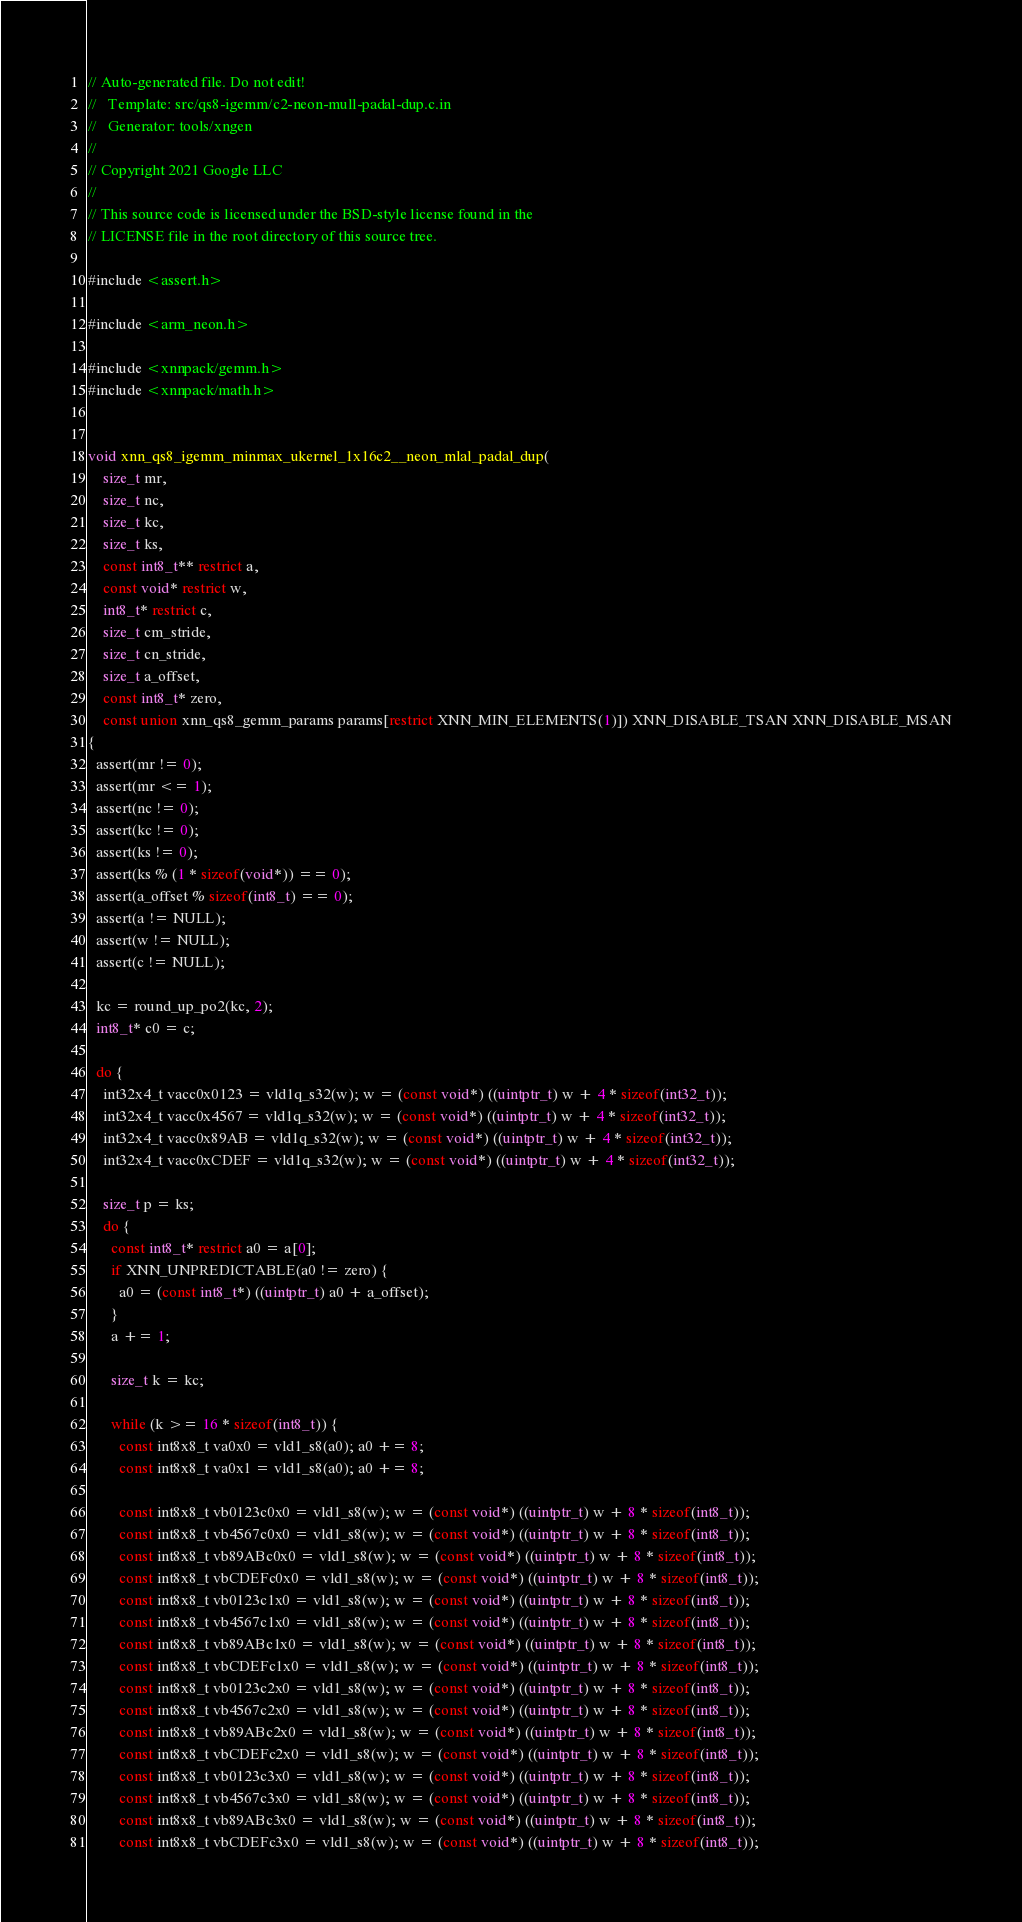Convert code to text. <code><loc_0><loc_0><loc_500><loc_500><_C_>// Auto-generated file. Do not edit!
//   Template: src/qs8-igemm/c2-neon-mull-padal-dup.c.in
//   Generator: tools/xngen
//
// Copyright 2021 Google LLC
//
// This source code is licensed under the BSD-style license found in the
// LICENSE file in the root directory of this source tree.

#include <assert.h>

#include <arm_neon.h>

#include <xnnpack/gemm.h>
#include <xnnpack/math.h>


void xnn_qs8_igemm_minmax_ukernel_1x16c2__neon_mlal_padal_dup(
    size_t mr,
    size_t nc,
    size_t kc,
    size_t ks,
    const int8_t** restrict a,
    const void* restrict w,
    int8_t* restrict c,
    size_t cm_stride,
    size_t cn_stride,
    size_t a_offset,
    const int8_t* zero,
    const union xnn_qs8_gemm_params params[restrict XNN_MIN_ELEMENTS(1)]) XNN_DISABLE_TSAN XNN_DISABLE_MSAN
{
  assert(mr != 0);
  assert(mr <= 1);
  assert(nc != 0);
  assert(kc != 0);
  assert(ks != 0);
  assert(ks % (1 * sizeof(void*)) == 0);
  assert(a_offset % sizeof(int8_t) == 0);
  assert(a != NULL);
  assert(w != NULL);
  assert(c != NULL);

  kc = round_up_po2(kc, 2);
  int8_t* c0 = c;

  do {
    int32x4_t vacc0x0123 = vld1q_s32(w); w = (const void*) ((uintptr_t) w + 4 * sizeof(int32_t));
    int32x4_t vacc0x4567 = vld1q_s32(w); w = (const void*) ((uintptr_t) w + 4 * sizeof(int32_t));
    int32x4_t vacc0x89AB = vld1q_s32(w); w = (const void*) ((uintptr_t) w + 4 * sizeof(int32_t));
    int32x4_t vacc0xCDEF = vld1q_s32(w); w = (const void*) ((uintptr_t) w + 4 * sizeof(int32_t));

    size_t p = ks;
    do {
      const int8_t* restrict a0 = a[0];
      if XNN_UNPREDICTABLE(a0 != zero) {
        a0 = (const int8_t*) ((uintptr_t) a0 + a_offset);
      }
      a += 1;

      size_t k = kc;

      while (k >= 16 * sizeof(int8_t)) {
        const int8x8_t va0x0 = vld1_s8(a0); a0 += 8;
        const int8x8_t va0x1 = vld1_s8(a0); a0 += 8;

        const int8x8_t vb0123c0x0 = vld1_s8(w); w = (const void*) ((uintptr_t) w + 8 * sizeof(int8_t));
        const int8x8_t vb4567c0x0 = vld1_s8(w); w = (const void*) ((uintptr_t) w + 8 * sizeof(int8_t));
        const int8x8_t vb89ABc0x0 = vld1_s8(w); w = (const void*) ((uintptr_t) w + 8 * sizeof(int8_t));
        const int8x8_t vbCDEFc0x0 = vld1_s8(w); w = (const void*) ((uintptr_t) w + 8 * sizeof(int8_t));
        const int8x8_t vb0123c1x0 = vld1_s8(w); w = (const void*) ((uintptr_t) w + 8 * sizeof(int8_t));
        const int8x8_t vb4567c1x0 = vld1_s8(w); w = (const void*) ((uintptr_t) w + 8 * sizeof(int8_t));
        const int8x8_t vb89ABc1x0 = vld1_s8(w); w = (const void*) ((uintptr_t) w + 8 * sizeof(int8_t));
        const int8x8_t vbCDEFc1x0 = vld1_s8(w); w = (const void*) ((uintptr_t) w + 8 * sizeof(int8_t));
        const int8x8_t vb0123c2x0 = vld1_s8(w); w = (const void*) ((uintptr_t) w + 8 * sizeof(int8_t));
        const int8x8_t vb4567c2x0 = vld1_s8(w); w = (const void*) ((uintptr_t) w + 8 * sizeof(int8_t));
        const int8x8_t vb89ABc2x0 = vld1_s8(w); w = (const void*) ((uintptr_t) w + 8 * sizeof(int8_t));
        const int8x8_t vbCDEFc2x0 = vld1_s8(w); w = (const void*) ((uintptr_t) w + 8 * sizeof(int8_t));
        const int8x8_t vb0123c3x0 = vld1_s8(w); w = (const void*) ((uintptr_t) w + 8 * sizeof(int8_t));
        const int8x8_t vb4567c3x0 = vld1_s8(w); w = (const void*) ((uintptr_t) w + 8 * sizeof(int8_t));
        const int8x8_t vb89ABc3x0 = vld1_s8(w); w = (const void*) ((uintptr_t) w + 8 * sizeof(int8_t));
        const int8x8_t vbCDEFc3x0 = vld1_s8(w); w = (const void*) ((uintptr_t) w + 8 * sizeof(int8_t));
</code> 